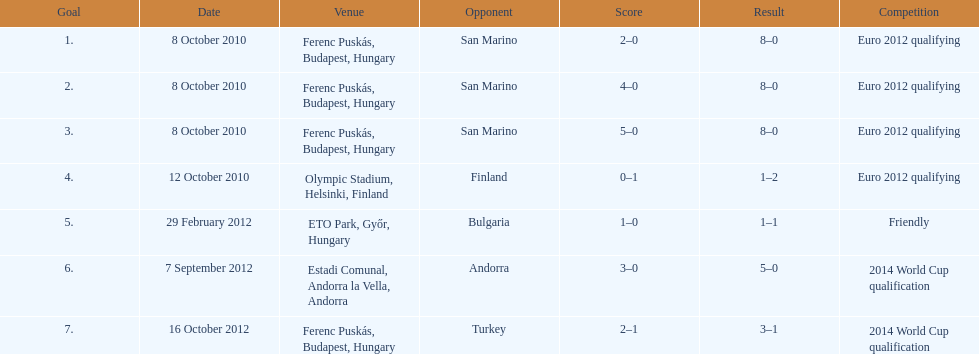What is the quantity of goals ádám szalai scored against san marino in 2010? 3. 